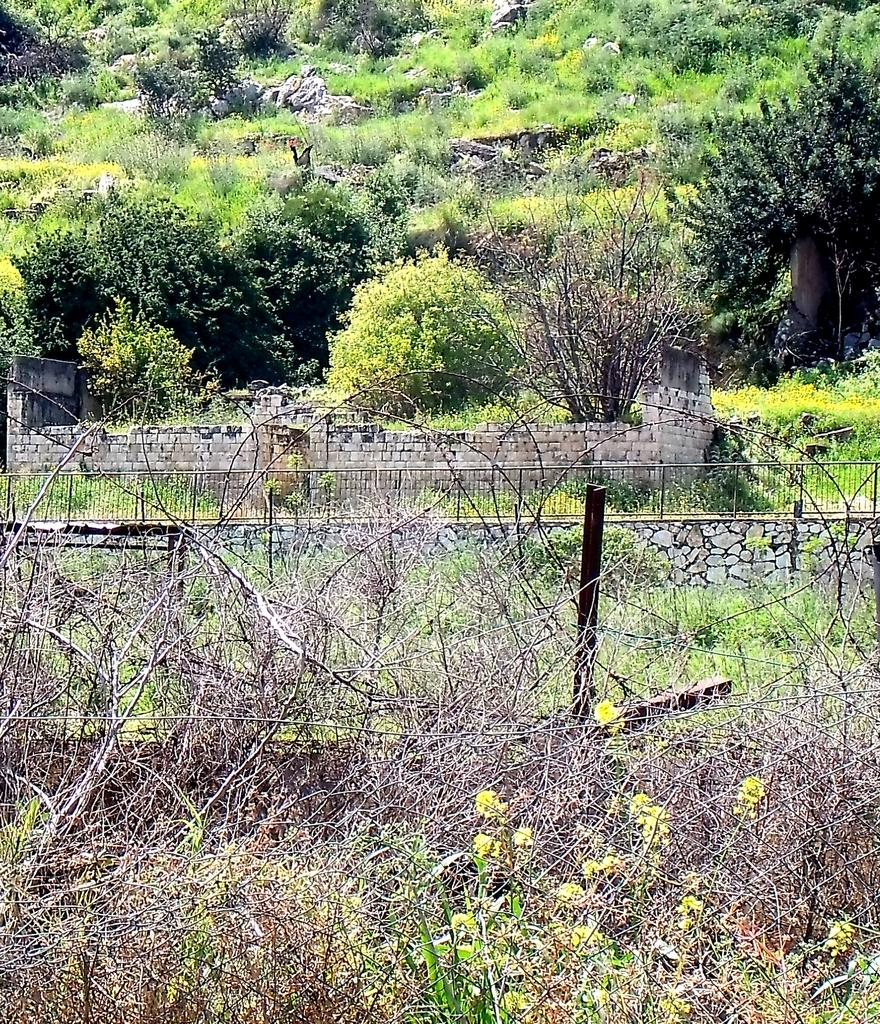What type of vegetation can be seen in the image? There are plants, grass, trees, and stones visible in the image. What objects can be seen in the image besides vegetation? There are rods visible in the image. What can be seen in the background of the image? In the background, there are walls, a fence, plants, trees, and grass. How many apples are hanging from the rods in the image? There are no apples present in the image; only plants, rods, and various background elements can be seen. What type of payment is being made in the image? There is no payment being made in the image; it features plants, rods, and various background elements. 